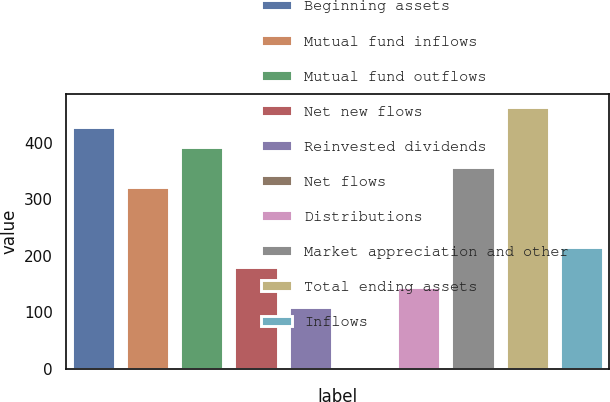Convert chart to OTSL. <chart><loc_0><loc_0><loc_500><loc_500><bar_chart><fcel>Beginning assets<fcel>Mutual fund inflows<fcel>Mutual fund outflows<fcel>Net new flows<fcel>Reinvested dividends<fcel>Net flows<fcel>Distributions<fcel>Market appreciation and other<fcel>Total ending assets<fcel>Inflows<nl><fcel>427.34<fcel>321.38<fcel>392.02<fcel>180.1<fcel>109.46<fcel>3.5<fcel>144.78<fcel>356.7<fcel>462.66<fcel>215.42<nl></chart> 